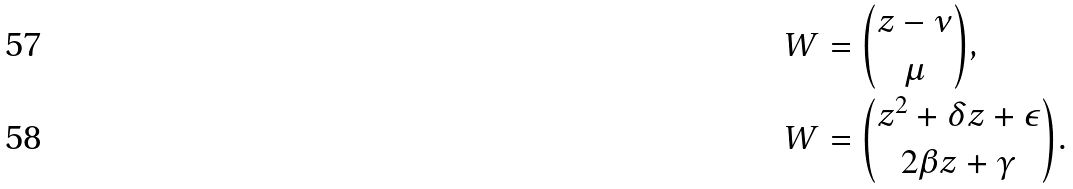<formula> <loc_0><loc_0><loc_500><loc_500>W & = \binom { z - \nu } { \mu } , \\ W & = \binom { z ^ { 2 } + \delta z + \epsilon } { 2 \beta z + \gamma } .</formula> 